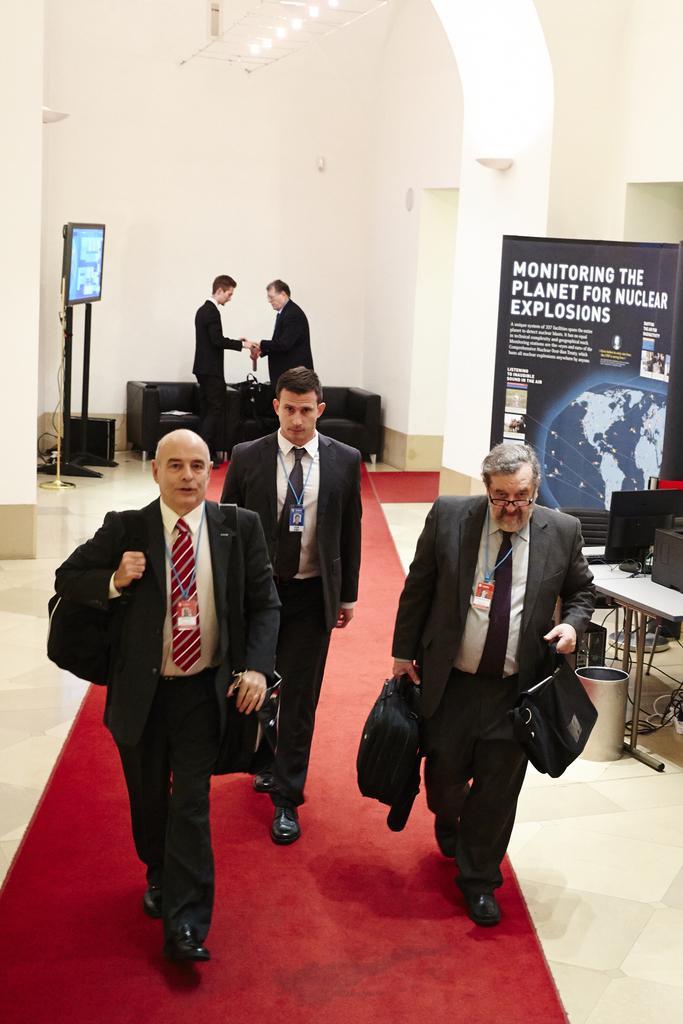How would you summarize this image in a sentence or two? In the image there are three men walking on the red carpet in black suits and behind them two men shaking hands in front of sofa and there is a tv on the left side of them, on the right side there is a banner. 